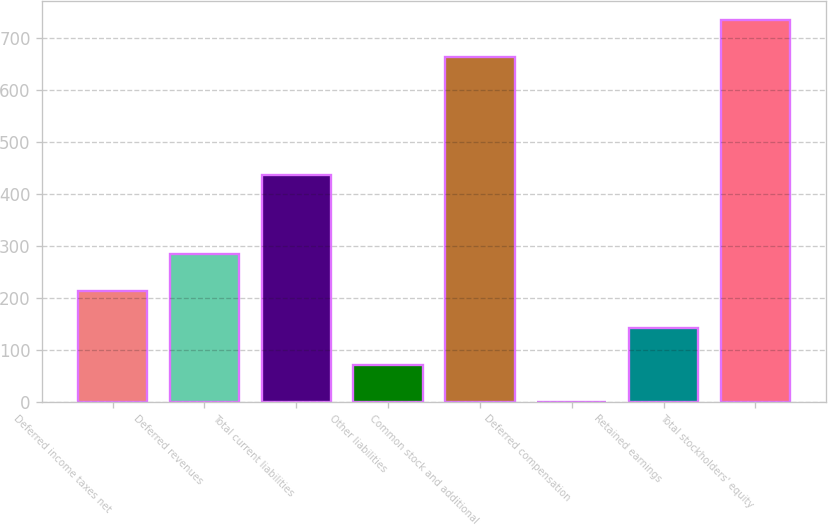Convert chart to OTSL. <chart><loc_0><loc_0><loc_500><loc_500><bar_chart><fcel>Deferred income taxes net<fcel>Deferred revenues<fcel>Total current liabilities<fcel>Other liabilities<fcel>Common stock and additional<fcel>Deferred compensation<fcel>Retained earnings<fcel>Total stockholders' equity<nl><fcel>213.31<fcel>284.38<fcel>436.9<fcel>71.17<fcel>664.7<fcel>0.1<fcel>142.24<fcel>735.77<nl></chart> 